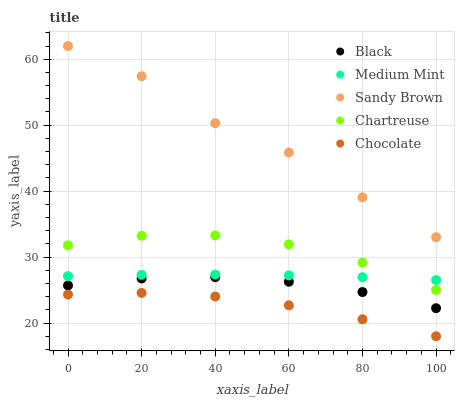Does Chocolate have the minimum area under the curve?
Answer yes or no. Yes. Does Sandy Brown have the maximum area under the curve?
Answer yes or no. Yes. Does Chartreuse have the minimum area under the curve?
Answer yes or no. No. Does Chartreuse have the maximum area under the curve?
Answer yes or no. No. Is Medium Mint the smoothest?
Answer yes or no. Yes. Is Sandy Brown the roughest?
Answer yes or no. Yes. Is Chartreuse the smoothest?
Answer yes or no. No. Is Chartreuse the roughest?
Answer yes or no. No. Does Chocolate have the lowest value?
Answer yes or no. Yes. Does Chartreuse have the lowest value?
Answer yes or no. No. Does Sandy Brown have the highest value?
Answer yes or no. Yes. Does Chartreuse have the highest value?
Answer yes or no. No. Is Black less than Medium Mint?
Answer yes or no. Yes. Is Medium Mint greater than Black?
Answer yes or no. Yes. Does Chartreuse intersect Medium Mint?
Answer yes or no. Yes. Is Chartreuse less than Medium Mint?
Answer yes or no. No. Is Chartreuse greater than Medium Mint?
Answer yes or no. No. Does Black intersect Medium Mint?
Answer yes or no. No. 